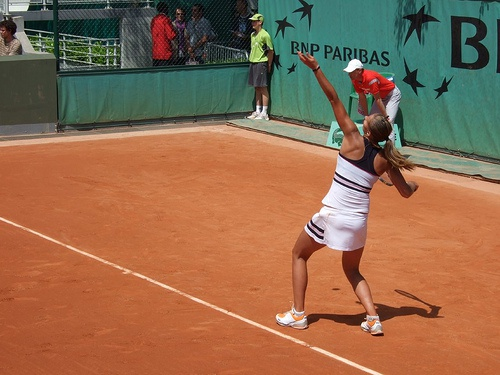Describe the objects in this image and their specific colors. I can see people in gray, lavender, maroon, brown, and black tones, people in gray, maroon, brown, lightgray, and darkgray tones, people in gray, black, maroon, and olive tones, people in gray, brown, black, and maroon tones, and people in gray, black, and maroon tones in this image. 